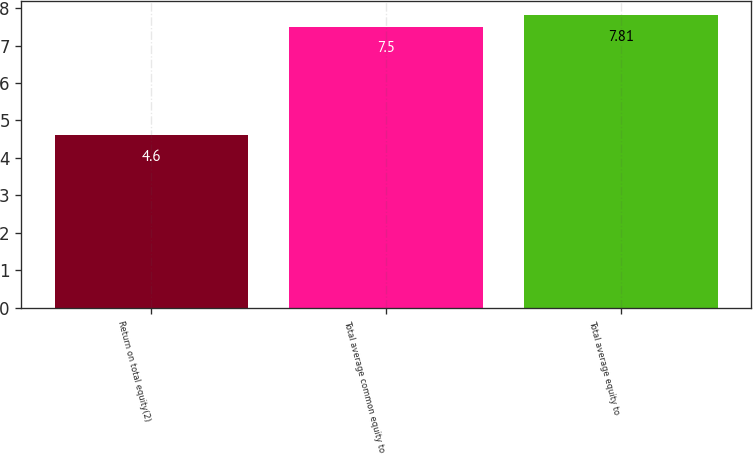<chart> <loc_0><loc_0><loc_500><loc_500><bar_chart><fcel>Return on total equity(2)<fcel>Total average common equity to<fcel>Total average equity to<nl><fcel>4.6<fcel>7.5<fcel>7.81<nl></chart> 